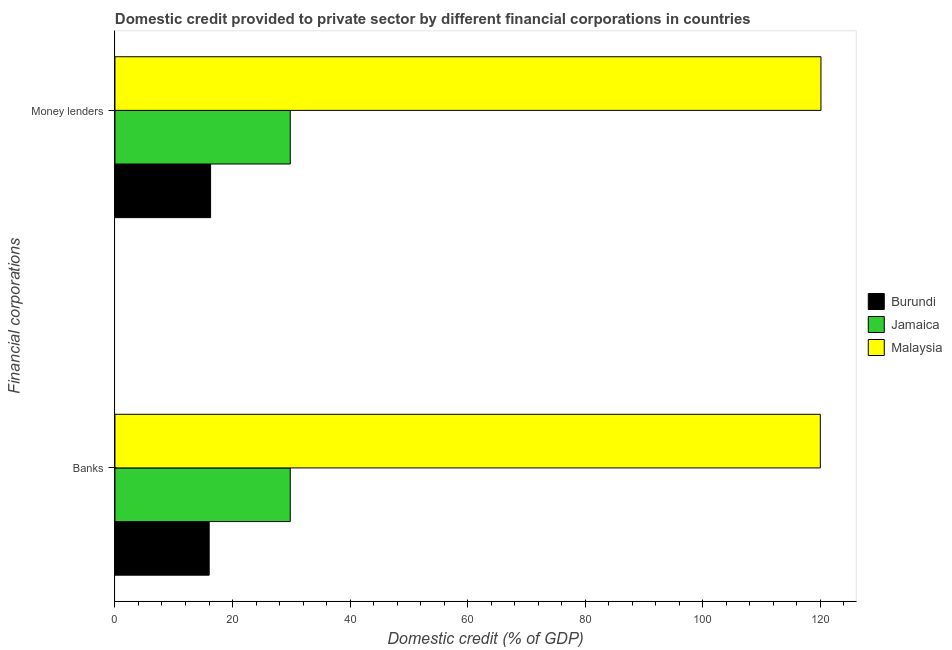How many groups of bars are there?
Make the answer very short. 2. How many bars are there on the 1st tick from the top?
Your answer should be compact. 3. What is the label of the 1st group of bars from the top?
Ensure brevity in your answer.  Money lenders. What is the domestic credit provided by money lenders in Malaysia?
Offer a very short reply. 120.09. Across all countries, what is the maximum domestic credit provided by banks?
Ensure brevity in your answer.  119.98. Across all countries, what is the minimum domestic credit provided by banks?
Your answer should be very brief. 16.03. In which country was the domestic credit provided by banks maximum?
Ensure brevity in your answer.  Malaysia. In which country was the domestic credit provided by banks minimum?
Provide a short and direct response. Burundi. What is the total domestic credit provided by banks in the graph?
Provide a succinct answer. 165.83. What is the difference between the domestic credit provided by banks in Malaysia and that in Burundi?
Keep it short and to the point. 103.95. What is the difference between the domestic credit provided by banks in Malaysia and the domestic credit provided by money lenders in Burundi?
Your response must be concise. 103.72. What is the average domestic credit provided by banks per country?
Your answer should be very brief. 55.28. What is the difference between the domestic credit provided by money lenders and domestic credit provided by banks in Burundi?
Offer a very short reply. 0.24. What is the ratio of the domestic credit provided by money lenders in Burundi to that in Malaysia?
Keep it short and to the point. 0.14. Is the domestic credit provided by banks in Malaysia less than that in Jamaica?
Your response must be concise. No. In how many countries, is the domestic credit provided by money lenders greater than the average domestic credit provided by money lenders taken over all countries?
Ensure brevity in your answer.  1. What does the 2nd bar from the top in Money lenders represents?
Provide a succinct answer. Jamaica. What does the 2nd bar from the bottom in Money lenders represents?
Offer a terse response. Jamaica. Are all the bars in the graph horizontal?
Ensure brevity in your answer.  Yes. Does the graph contain any zero values?
Offer a terse response. No. Does the graph contain grids?
Keep it short and to the point. No. How many legend labels are there?
Your response must be concise. 3. What is the title of the graph?
Your answer should be compact. Domestic credit provided to private sector by different financial corporations in countries. What is the label or title of the X-axis?
Keep it short and to the point. Domestic credit (% of GDP). What is the label or title of the Y-axis?
Give a very brief answer. Financial corporations. What is the Domestic credit (% of GDP) in Burundi in Banks?
Provide a short and direct response. 16.03. What is the Domestic credit (% of GDP) of Jamaica in Banks?
Provide a succinct answer. 29.82. What is the Domestic credit (% of GDP) of Malaysia in Banks?
Your answer should be very brief. 119.98. What is the Domestic credit (% of GDP) in Burundi in Money lenders?
Make the answer very short. 16.27. What is the Domestic credit (% of GDP) of Jamaica in Money lenders?
Your answer should be compact. 29.82. What is the Domestic credit (% of GDP) of Malaysia in Money lenders?
Your answer should be very brief. 120.09. Across all Financial corporations, what is the maximum Domestic credit (% of GDP) of Burundi?
Offer a very short reply. 16.27. Across all Financial corporations, what is the maximum Domestic credit (% of GDP) of Jamaica?
Provide a short and direct response. 29.82. Across all Financial corporations, what is the maximum Domestic credit (% of GDP) of Malaysia?
Give a very brief answer. 120.09. Across all Financial corporations, what is the minimum Domestic credit (% of GDP) in Burundi?
Give a very brief answer. 16.03. Across all Financial corporations, what is the minimum Domestic credit (% of GDP) in Jamaica?
Offer a terse response. 29.82. Across all Financial corporations, what is the minimum Domestic credit (% of GDP) in Malaysia?
Provide a short and direct response. 119.98. What is the total Domestic credit (% of GDP) of Burundi in the graph?
Offer a very short reply. 32.29. What is the total Domestic credit (% of GDP) of Jamaica in the graph?
Make the answer very short. 59.64. What is the total Domestic credit (% of GDP) in Malaysia in the graph?
Provide a short and direct response. 240.07. What is the difference between the Domestic credit (% of GDP) of Burundi in Banks and that in Money lenders?
Keep it short and to the point. -0.24. What is the difference between the Domestic credit (% of GDP) of Jamaica in Banks and that in Money lenders?
Your answer should be compact. 0. What is the difference between the Domestic credit (% of GDP) of Malaysia in Banks and that in Money lenders?
Provide a short and direct response. -0.11. What is the difference between the Domestic credit (% of GDP) of Burundi in Banks and the Domestic credit (% of GDP) of Jamaica in Money lenders?
Your response must be concise. -13.79. What is the difference between the Domestic credit (% of GDP) of Burundi in Banks and the Domestic credit (% of GDP) of Malaysia in Money lenders?
Provide a short and direct response. -104.06. What is the difference between the Domestic credit (% of GDP) in Jamaica in Banks and the Domestic credit (% of GDP) in Malaysia in Money lenders?
Your response must be concise. -90.27. What is the average Domestic credit (% of GDP) in Burundi per Financial corporations?
Provide a succinct answer. 16.15. What is the average Domestic credit (% of GDP) of Jamaica per Financial corporations?
Ensure brevity in your answer.  29.82. What is the average Domestic credit (% of GDP) in Malaysia per Financial corporations?
Your answer should be very brief. 120.04. What is the difference between the Domestic credit (% of GDP) of Burundi and Domestic credit (% of GDP) of Jamaica in Banks?
Your answer should be very brief. -13.79. What is the difference between the Domestic credit (% of GDP) in Burundi and Domestic credit (% of GDP) in Malaysia in Banks?
Your answer should be very brief. -103.95. What is the difference between the Domestic credit (% of GDP) of Jamaica and Domestic credit (% of GDP) of Malaysia in Banks?
Provide a succinct answer. -90.16. What is the difference between the Domestic credit (% of GDP) in Burundi and Domestic credit (% of GDP) in Jamaica in Money lenders?
Provide a short and direct response. -13.55. What is the difference between the Domestic credit (% of GDP) in Burundi and Domestic credit (% of GDP) in Malaysia in Money lenders?
Your answer should be compact. -103.82. What is the difference between the Domestic credit (% of GDP) in Jamaica and Domestic credit (% of GDP) in Malaysia in Money lenders?
Give a very brief answer. -90.27. What is the difference between the highest and the second highest Domestic credit (% of GDP) of Burundi?
Your answer should be very brief. 0.24. What is the difference between the highest and the second highest Domestic credit (% of GDP) of Malaysia?
Keep it short and to the point. 0.11. What is the difference between the highest and the lowest Domestic credit (% of GDP) of Burundi?
Ensure brevity in your answer.  0.24. What is the difference between the highest and the lowest Domestic credit (% of GDP) in Malaysia?
Make the answer very short. 0.11. 